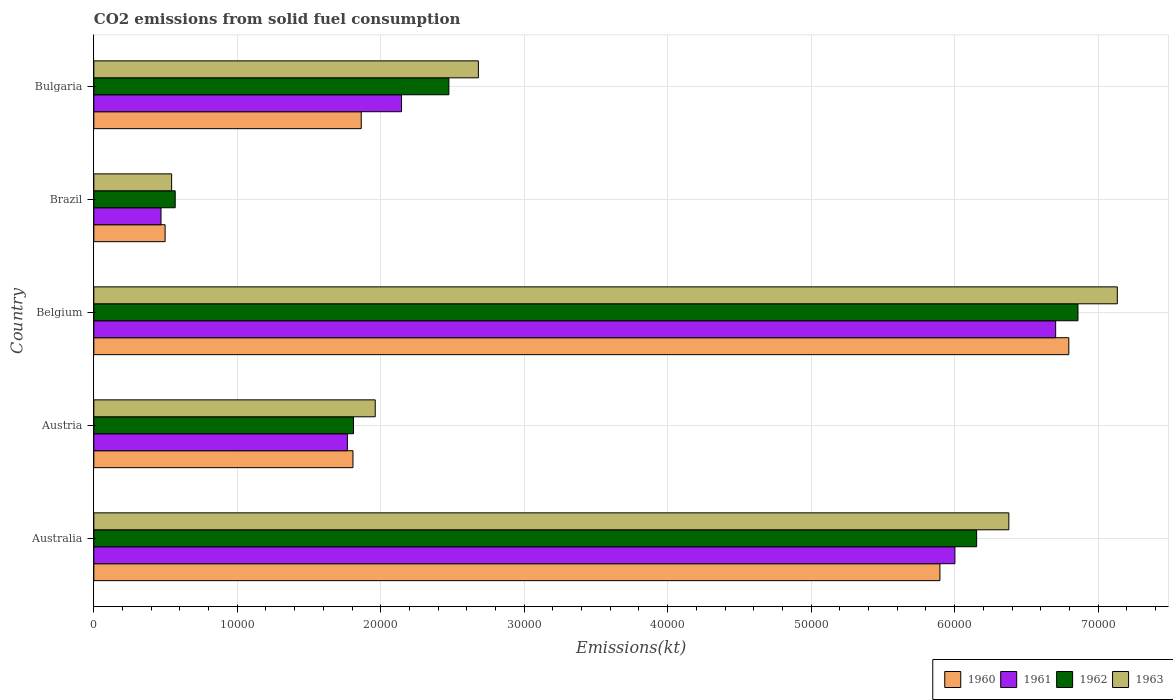How many different coloured bars are there?
Provide a succinct answer. 4. Are the number of bars on each tick of the Y-axis equal?
Your response must be concise. Yes. How many bars are there on the 5th tick from the bottom?
Make the answer very short. 4. What is the amount of CO2 emitted in 1960 in Austria?
Your answer should be compact. 1.81e+04. Across all countries, what is the maximum amount of CO2 emitted in 1961?
Ensure brevity in your answer.  6.70e+04. Across all countries, what is the minimum amount of CO2 emitted in 1962?
Give a very brief answer. 5672.85. In which country was the amount of CO2 emitted in 1960 maximum?
Your response must be concise. Belgium. What is the total amount of CO2 emitted in 1960 in the graph?
Provide a short and direct response. 1.69e+05. What is the difference between the amount of CO2 emitted in 1963 in Australia and that in Belgium?
Provide a succinct answer. -7561.35. What is the difference between the amount of CO2 emitted in 1962 in Australia and the amount of CO2 emitted in 1960 in Bulgaria?
Give a very brief answer. 4.29e+04. What is the average amount of CO2 emitted in 1961 per country?
Give a very brief answer. 3.42e+04. What is the difference between the amount of CO2 emitted in 1960 and amount of CO2 emitted in 1962 in Austria?
Keep it short and to the point. -36.67. In how many countries, is the amount of CO2 emitted in 1961 greater than 8000 kt?
Give a very brief answer. 4. What is the ratio of the amount of CO2 emitted in 1960 in Austria to that in Bulgaria?
Offer a very short reply. 0.97. Is the amount of CO2 emitted in 1962 in Belgium less than that in Brazil?
Make the answer very short. No. What is the difference between the highest and the second highest amount of CO2 emitted in 1963?
Keep it short and to the point. 7561.35. What is the difference between the highest and the lowest amount of CO2 emitted in 1962?
Make the answer very short. 6.29e+04. In how many countries, is the amount of CO2 emitted in 1961 greater than the average amount of CO2 emitted in 1961 taken over all countries?
Your response must be concise. 2. Is it the case that in every country, the sum of the amount of CO2 emitted in 1960 and amount of CO2 emitted in 1962 is greater than the sum of amount of CO2 emitted in 1963 and amount of CO2 emitted in 1961?
Offer a terse response. No. What does the 3rd bar from the top in Austria represents?
Offer a terse response. 1961. What does the 4th bar from the bottom in Bulgaria represents?
Offer a very short reply. 1963. How many bars are there?
Keep it short and to the point. 20. Are all the bars in the graph horizontal?
Give a very brief answer. Yes. How many countries are there in the graph?
Give a very brief answer. 5. What is the difference between two consecutive major ticks on the X-axis?
Give a very brief answer. 10000. Does the graph contain any zero values?
Give a very brief answer. No. Does the graph contain grids?
Your answer should be compact. Yes. What is the title of the graph?
Offer a terse response. CO2 emissions from solid fuel consumption. Does "1968" appear as one of the legend labels in the graph?
Keep it short and to the point. No. What is the label or title of the X-axis?
Your response must be concise. Emissions(kt). What is the label or title of the Y-axis?
Your answer should be very brief. Country. What is the Emissions(kt) in 1960 in Australia?
Your answer should be compact. 5.90e+04. What is the Emissions(kt) in 1961 in Australia?
Provide a short and direct response. 6.00e+04. What is the Emissions(kt) of 1962 in Australia?
Provide a short and direct response. 6.15e+04. What is the Emissions(kt) of 1963 in Australia?
Make the answer very short. 6.38e+04. What is the Emissions(kt) of 1960 in Austria?
Ensure brevity in your answer.  1.81e+04. What is the Emissions(kt) in 1961 in Austria?
Give a very brief answer. 1.77e+04. What is the Emissions(kt) in 1962 in Austria?
Give a very brief answer. 1.81e+04. What is the Emissions(kt) of 1963 in Austria?
Provide a short and direct response. 1.96e+04. What is the Emissions(kt) of 1960 in Belgium?
Ensure brevity in your answer.  6.80e+04. What is the Emissions(kt) in 1961 in Belgium?
Provide a short and direct response. 6.70e+04. What is the Emissions(kt) of 1962 in Belgium?
Provide a short and direct response. 6.86e+04. What is the Emissions(kt) in 1963 in Belgium?
Offer a very short reply. 7.13e+04. What is the Emissions(kt) in 1960 in Brazil?
Provide a succinct answer. 4968.78. What is the Emissions(kt) in 1961 in Brazil?
Your answer should be very brief. 4682.76. What is the Emissions(kt) of 1962 in Brazil?
Keep it short and to the point. 5672.85. What is the Emissions(kt) of 1963 in Brazil?
Make the answer very short. 5423.49. What is the Emissions(kt) of 1960 in Bulgaria?
Give a very brief answer. 1.86e+04. What is the Emissions(kt) in 1961 in Bulgaria?
Provide a short and direct response. 2.14e+04. What is the Emissions(kt) of 1962 in Bulgaria?
Ensure brevity in your answer.  2.47e+04. What is the Emissions(kt) in 1963 in Bulgaria?
Ensure brevity in your answer.  2.68e+04. Across all countries, what is the maximum Emissions(kt) of 1960?
Offer a terse response. 6.80e+04. Across all countries, what is the maximum Emissions(kt) of 1961?
Make the answer very short. 6.70e+04. Across all countries, what is the maximum Emissions(kt) of 1962?
Give a very brief answer. 6.86e+04. Across all countries, what is the maximum Emissions(kt) in 1963?
Give a very brief answer. 7.13e+04. Across all countries, what is the minimum Emissions(kt) of 1960?
Ensure brevity in your answer.  4968.78. Across all countries, what is the minimum Emissions(kt) in 1961?
Ensure brevity in your answer.  4682.76. Across all countries, what is the minimum Emissions(kt) in 1962?
Your answer should be compact. 5672.85. Across all countries, what is the minimum Emissions(kt) of 1963?
Offer a terse response. 5423.49. What is the total Emissions(kt) of 1960 in the graph?
Give a very brief answer. 1.69e+05. What is the total Emissions(kt) of 1961 in the graph?
Make the answer very short. 1.71e+05. What is the total Emissions(kt) in 1962 in the graph?
Provide a short and direct response. 1.79e+05. What is the total Emissions(kt) of 1963 in the graph?
Your answer should be very brief. 1.87e+05. What is the difference between the Emissions(kt) in 1960 in Australia and that in Austria?
Ensure brevity in your answer.  4.09e+04. What is the difference between the Emissions(kt) in 1961 in Australia and that in Austria?
Give a very brief answer. 4.23e+04. What is the difference between the Emissions(kt) of 1962 in Australia and that in Austria?
Ensure brevity in your answer.  4.34e+04. What is the difference between the Emissions(kt) of 1963 in Australia and that in Austria?
Keep it short and to the point. 4.42e+04. What is the difference between the Emissions(kt) in 1960 in Australia and that in Belgium?
Your answer should be compact. -8984.15. What is the difference between the Emissions(kt) in 1961 in Australia and that in Belgium?
Make the answer very short. -7022.31. What is the difference between the Emissions(kt) of 1962 in Australia and that in Belgium?
Your answer should be very brief. -7062.64. What is the difference between the Emissions(kt) of 1963 in Australia and that in Belgium?
Make the answer very short. -7561.35. What is the difference between the Emissions(kt) of 1960 in Australia and that in Brazil?
Ensure brevity in your answer.  5.40e+04. What is the difference between the Emissions(kt) in 1961 in Australia and that in Brazil?
Your response must be concise. 5.53e+04. What is the difference between the Emissions(kt) of 1962 in Australia and that in Brazil?
Your answer should be compact. 5.59e+04. What is the difference between the Emissions(kt) of 1963 in Australia and that in Brazil?
Your response must be concise. 5.84e+04. What is the difference between the Emissions(kt) of 1960 in Australia and that in Bulgaria?
Make the answer very short. 4.03e+04. What is the difference between the Emissions(kt) in 1961 in Australia and that in Bulgaria?
Provide a short and direct response. 3.86e+04. What is the difference between the Emissions(kt) of 1962 in Australia and that in Bulgaria?
Offer a terse response. 3.68e+04. What is the difference between the Emissions(kt) in 1963 in Australia and that in Bulgaria?
Offer a terse response. 3.70e+04. What is the difference between the Emissions(kt) of 1960 in Austria and that in Belgium?
Your response must be concise. -4.99e+04. What is the difference between the Emissions(kt) of 1961 in Austria and that in Belgium?
Your response must be concise. -4.94e+04. What is the difference between the Emissions(kt) of 1962 in Austria and that in Belgium?
Provide a succinct answer. -5.05e+04. What is the difference between the Emissions(kt) of 1963 in Austria and that in Belgium?
Give a very brief answer. -5.17e+04. What is the difference between the Emissions(kt) in 1960 in Austria and that in Brazil?
Provide a short and direct response. 1.31e+04. What is the difference between the Emissions(kt) of 1961 in Austria and that in Brazil?
Ensure brevity in your answer.  1.30e+04. What is the difference between the Emissions(kt) of 1962 in Austria and that in Brazil?
Offer a very short reply. 1.24e+04. What is the difference between the Emissions(kt) of 1963 in Austria and that in Brazil?
Your response must be concise. 1.42e+04. What is the difference between the Emissions(kt) of 1960 in Austria and that in Bulgaria?
Offer a terse response. -575.72. What is the difference between the Emissions(kt) in 1961 in Austria and that in Bulgaria?
Make the answer very short. -3773.34. What is the difference between the Emissions(kt) of 1962 in Austria and that in Bulgaria?
Keep it short and to the point. -6648.27. What is the difference between the Emissions(kt) in 1963 in Austria and that in Bulgaria?
Give a very brief answer. -7190.99. What is the difference between the Emissions(kt) of 1960 in Belgium and that in Brazil?
Your answer should be compact. 6.30e+04. What is the difference between the Emissions(kt) of 1961 in Belgium and that in Brazil?
Make the answer very short. 6.24e+04. What is the difference between the Emissions(kt) in 1962 in Belgium and that in Brazil?
Ensure brevity in your answer.  6.29e+04. What is the difference between the Emissions(kt) in 1963 in Belgium and that in Brazil?
Your answer should be compact. 6.59e+04. What is the difference between the Emissions(kt) of 1960 in Belgium and that in Bulgaria?
Keep it short and to the point. 4.93e+04. What is the difference between the Emissions(kt) in 1961 in Belgium and that in Bulgaria?
Give a very brief answer. 4.56e+04. What is the difference between the Emissions(kt) in 1962 in Belgium and that in Bulgaria?
Provide a succinct answer. 4.38e+04. What is the difference between the Emissions(kt) in 1963 in Belgium and that in Bulgaria?
Your answer should be very brief. 4.45e+04. What is the difference between the Emissions(kt) in 1960 in Brazil and that in Bulgaria?
Give a very brief answer. -1.37e+04. What is the difference between the Emissions(kt) of 1961 in Brazil and that in Bulgaria?
Offer a terse response. -1.68e+04. What is the difference between the Emissions(kt) of 1962 in Brazil and that in Bulgaria?
Your answer should be very brief. -1.91e+04. What is the difference between the Emissions(kt) in 1963 in Brazil and that in Bulgaria?
Give a very brief answer. -2.14e+04. What is the difference between the Emissions(kt) in 1960 in Australia and the Emissions(kt) in 1961 in Austria?
Ensure brevity in your answer.  4.13e+04. What is the difference between the Emissions(kt) of 1960 in Australia and the Emissions(kt) of 1962 in Austria?
Your answer should be compact. 4.09e+04. What is the difference between the Emissions(kt) of 1960 in Australia and the Emissions(kt) of 1963 in Austria?
Offer a very short reply. 3.94e+04. What is the difference between the Emissions(kt) of 1961 in Australia and the Emissions(kt) of 1962 in Austria?
Provide a short and direct response. 4.19e+04. What is the difference between the Emissions(kt) of 1961 in Australia and the Emissions(kt) of 1963 in Austria?
Your response must be concise. 4.04e+04. What is the difference between the Emissions(kt) of 1962 in Australia and the Emissions(kt) of 1963 in Austria?
Your answer should be very brief. 4.19e+04. What is the difference between the Emissions(kt) of 1960 in Australia and the Emissions(kt) of 1961 in Belgium?
Make the answer very short. -8067.4. What is the difference between the Emissions(kt) in 1960 in Australia and the Emissions(kt) in 1962 in Belgium?
Provide a short and direct response. -9622.21. What is the difference between the Emissions(kt) of 1960 in Australia and the Emissions(kt) of 1963 in Belgium?
Your answer should be very brief. -1.24e+04. What is the difference between the Emissions(kt) in 1961 in Australia and the Emissions(kt) in 1962 in Belgium?
Offer a terse response. -8577.11. What is the difference between the Emissions(kt) of 1961 in Australia and the Emissions(kt) of 1963 in Belgium?
Your response must be concise. -1.13e+04. What is the difference between the Emissions(kt) in 1962 in Australia and the Emissions(kt) in 1963 in Belgium?
Offer a terse response. -9805.56. What is the difference between the Emissions(kt) in 1960 in Australia and the Emissions(kt) in 1961 in Brazil?
Your answer should be compact. 5.43e+04. What is the difference between the Emissions(kt) of 1960 in Australia and the Emissions(kt) of 1962 in Brazil?
Your response must be concise. 5.33e+04. What is the difference between the Emissions(kt) in 1960 in Australia and the Emissions(kt) in 1963 in Brazil?
Your response must be concise. 5.36e+04. What is the difference between the Emissions(kt) of 1961 in Australia and the Emissions(kt) of 1962 in Brazil?
Your answer should be compact. 5.43e+04. What is the difference between the Emissions(kt) in 1961 in Australia and the Emissions(kt) in 1963 in Brazil?
Offer a very short reply. 5.46e+04. What is the difference between the Emissions(kt) in 1962 in Australia and the Emissions(kt) in 1963 in Brazil?
Your response must be concise. 5.61e+04. What is the difference between the Emissions(kt) in 1960 in Australia and the Emissions(kt) in 1961 in Bulgaria?
Keep it short and to the point. 3.75e+04. What is the difference between the Emissions(kt) of 1960 in Australia and the Emissions(kt) of 1962 in Bulgaria?
Ensure brevity in your answer.  3.42e+04. What is the difference between the Emissions(kt) in 1960 in Australia and the Emissions(kt) in 1963 in Bulgaria?
Make the answer very short. 3.22e+04. What is the difference between the Emissions(kt) of 1961 in Australia and the Emissions(kt) of 1962 in Bulgaria?
Your answer should be compact. 3.53e+04. What is the difference between the Emissions(kt) of 1961 in Australia and the Emissions(kt) of 1963 in Bulgaria?
Offer a terse response. 3.32e+04. What is the difference between the Emissions(kt) in 1962 in Australia and the Emissions(kt) in 1963 in Bulgaria?
Your answer should be very brief. 3.47e+04. What is the difference between the Emissions(kt) of 1960 in Austria and the Emissions(kt) of 1961 in Belgium?
Give a very brief answer. -4.90e+04. What is the difference between the Emissions(kt) of 1960 in Austria and the Emissions(kt) of 1962 in Belgium?
Ensure brevity in your answer.  -5.05e+04. What is the difference between the Emissions(kt) of 1960 in Austria and the Emissions(kt) of 1963 in Belgium?
Make the answer very short. -5.33e+04. What is the difference between the Emissions(kt) of 1961 in Austria and the Emissions(kt) of 1962 in Belgium?
Your response must be concise. -5.09e+04. What is the difference between the Emissions(kt) in 1961 in Austria and the Emissions(kt) in 1963 in Belgium?
Offer a very short reply. -5.37e+04. What is the difference between the Emissions(kt) of 1962 in Austria and the Emissions(kt) of 1963 in Belgium?
Offer a terse response. -5.32e+04. What is the difference between the Emissions(kt) of 1960 in Austria and the Emissions(kt) of 1961 in Brazil?
Offer a terse response. 1.34e+04. What is the difference between the Emissions(kt) in 1960 in Austria and the Emissions(kt) in 1962 in Brazil?
Provide a short and direct response. 1.24e+04. What is the difference between the Emissions(kt) in 1960 in Austria and the Emissions(kt) in 1963 in Brazil?
Your answer should be compact. 1.26e+04. What is the difference between the Emissions(kt) in 1961 in Austria and the Emissions(kt) in 1962 in Brazil?
Your response must be concise. 1.20e+04. What is the difference between the Emissions(kt) of 1961 in Austria and the Emissions(kt) of 1963 in Brazil?
Offer a very short reply. 1.23e+04. What is the difference between the Emissions(kt) in 1962 in Austria and the Emissions(kt) in 1963 in Brazil?
Your answer should be very brief. 1.27e+04. What is the difference between the Emissions(kt) of 1960 in Austria and the Emissions(kt) of 1961 in Bulgaria?
Give a very brief answer. -3384.64. What is the difference between the Emissions(kt) of 1960 in Austria and the Emissions(kt) of 1962 in Bulgaria?
Offer a very short reply. -6684.94. What is the difference between the Emissions(kt) in 1960 in Austria and the Emissions(kt) in 1963 in Bulgaria?
Provide a succinct answer. -8742.13. What is the difference between the Emissions(kt) of 1961 in Austria and the Emissions(kt) of 1962 in Bulgaria?
Your answer should be very brief. -7073.64. What is the difference between the Emissions(kt) in 1961 in Austria and the Emissions(kt) in 1963 in Bulgaria?
Offer a very short reply. -9130.83. What is the difference between the Emissions(kt) in 1962 in Austria and the Emissions(kt) in 1963 in Bulgaria?
Ensure brevity in your answer.  -8705.46. What is the difference between the Emissions(kt) in 1960 in Belgium and the Emissions(kt) in 1961 in Brazil?
Offer a very short reply. 6.33e+04. What is the difference between the Emissions(kt) of 1960 in Belgium and the Emissions(kt) of 1962 in Brazil?
Keep it short and to the point. 6.23e+04. What is the difference between the Emissions(kt) of 1960 in Belgium and the Emissions(kt) of 1963 in Brazil?
Make the answer very short. 6.25e+04. What is the difference between the Emissions(kt) in 1961 in Belgium and the Emissions(kt) in 1962 in Brazil?
Your response must be concise. 6.14e+04. What is the difference between the Emissions(kt) of 1961 in Belgium and the Emissions(kt) of 1963 in Brazil?
Provide a short and direct response. 6.16e+04. What is the difference between the Emissions(kt) of 1962 in Belgium and the Emissions(kt) of 1963 in Brazil?
Make the answer very short. 6.32e+04. What is the difference between the Emissions(kt) in 1960 in Belgium and the Emissions(kt) in 1961 in Bulgaria?
Give a very brief answer. 4.65e+04. What is the difference between the Emissions(kt) of 1960 in Belgium and the Emissions(kt) of 1962 in Bulgaria?
Provide a succinct answer. 4.32e+04. What is the difference between the Emissions(kt) in 1960 in Belgium and the Emissions(kt) in 1963 in Bulgaria?
Provide a succinct answer. 4.12e+04. What is the difference between the Emissions(kt) in 1961 in Belgium and the Emissions(kt) in 1962 in Bulgaria?
Offer a terse response. 4.23e+04. What is the difference between the Emissions(kt) in 1961 in Belgium and the Emissions(kt) in 1963 in Bulgaria?
Provide a short and direct response. 4.02e+04. What is the difference between the Emissions(kt) in 1962 in Belgium and the Emissions(kt) in 1963 in Bulgaria?
Offer a terse response. 4.18e+04. What is the difference between the Emissions(kt) of 1960 in Brazil and the Emissions(kt) of 1961 in Bulgaria?
Provide a succinct answer. -1.65e+04. What is the difference between the Emissions(kt) of 1960 in Brazil and the Emissions(kt) of 1962 in Bulgaria?
Offer a terse response. -1.98e+04. What is the difference between the Emissions(kt) of 1960 in Brazil and the Emissions(kt) of 1963 in Bulgaria?
Your answer should be compact. -2.18e+04. What is the difference between the Emissions(kt) of 1961 in Brazil and the Emissions(kt) of 1962 in Bulgaria?
Provide a short and direct response. -2.01e+04. What is the difference between the Emissions(kt) in 1961 in Brazil and the Emissions(kt) in 1963 in Bulgaria?
Ensure brevity in your answer.  -2.21e+04. What is the difference between the Emissions(kt) of 1962 in Brazil and the Emissions(kt) of 1963 in Bulgaria?
Provide a short and direct response. -2.11e+04. What is the average Emissions(kt) in 1960 per country?
Offer a terse response. 3.37e+04. What is the average Emissions(kt) of 1961 per country?
Ensure brevity in your answer.  3.42e+04. What is the average Emissions(kt) in 1962 per country?
Ensure brevity in your answer.  3.57e+04. What is the average Emissions(kt) of 1963 per country?
Your response must be concise. 3.74e+04. What is the difference between the Emissions(kt) of 1960 and Emissions(kt) of 1961 in Australia?
Provide a succinct answer. -1045.1. What is the difference between the Emissions(kt) of 1960 and Emissions(kt) of 1962 in Australia?
Offer a very short reply. -2559.57. What is the difference between the Emissions(kt) of 1960 and Emissions(kt) of 1963 in Australia?
Offer a terse response. -4803.77. What is the difference between the Emissions(kt) of 1961 and Emissions(kt) of 1962 in Australia?
Your response must be concise. -1514.47. What is the difference between the Emissions(kt) in 1961 and Emissions(kt) in 1963 in Australia?
Make the answer very short. -3758.68. What is the difference between the Emissions(kt) in 1962 and Emissions(kt) in 1963 in Australia?
Offer a terse response. -2244.2. What is the difference between the Emissions(kt) in 1960 and Emissions(kt) in 1961 in Austria?
Provide a short and direct response. 388.7. What is the difference between the Emissions(kt) in 1960 and Emissions(kt) in 1962 in Austria?
Provide a short and direct response. -36.67. What is the difference between the Emissions(kt) in 1960 and Emissions(kt) in 1963 in Austria?
Make the answer very short. -1551.14. What is the difference between the Emissions(kt) of 1961 and Emissions(kt) of 1962 in Austria?
Make the answer very short. -425.37. What is the difference between the Emissions(kt) in 1961 and Emissions(kt) in 1963 in Austria?
Provide a short and direct response. -1939.84. What is the difference between the Emissions(kt) of 1962 and Emissions(kt) of 1963 in Austria?
Provide a short and direct response. -1514.47. What is the difference between the Emissions(kt) in 1960 and Emissions(kt) in 1961 in Belgium?
Your answer should be compact. 916.75. What is the difference between the Emissions(kt) in 1960 and Emissions(kt) in 1962 in Belgium?
Make the answer very short. -638.06. What is the difference between the Emissions(kt) in 1960 and Emissions(kt) in 1963 in Belgium?
Your answer should be very brief. -3380.97. What is the difference between the Emissions(kt) in 1961 and Emissions(kt) in 1962 in Belgium?
Offer a terse response. -1554.81. What is the difference between the Emissions(kt) of 1961 and Emissions(kt) of 1963 in Belgium?
Your answer should be very brief. -4297.72. What is the difference between the Emissions(kt) in 1962 and Emissions(kt) in 1963 in Belgium?
Your answer should be very brief. -2742.92. What is the difference between the Emissions(kt) of 1960 and Emissions(kt) of 1961 in Brazil?
Your answer should be very brief. 286.03. What is the difference between the Emissions(kt) of 1960 and Emissions(kt) of 1962 in Brazil?
Your response must be concise. -704.06. What is the difference between the Emissions(kt) of 1960 and Emissions(kt) of 1963 in Brazil?
Make the answer very short. -454.71. What is the difference between the Emissions(kt) in 1961 and Emissions(kt) in 1962 in Brazil?
Give a very brief answer. -990.09. What is the difference between the Emissions(kt) in 1961 and Emissions(kt) in 1963 in Brazil?
Your answer should be very brief. -740.73. What is the difference between the Emissions(kt) of 1962 and Emissions(kt) of 1963 in Brazil?
Provide a succinct answer. 249.36. What is the difference between the Emissions(kt) in 1960 and Emissions(kt) in 1961 in Bulgaria?
Make the answer very short. -2808.92. What is the difference between the Emissions(kt) in 1960 and Emissions(kt) in 1962 in Bulgaria?
Your response must be concise. -6109.22. What is the difference between the Emissions(kt) in 1960 and Emissions(kt) in 1963 in Bulgaria?
Give a very brief answer. -8166.41. What is the difference between the Emissions(kt) in 1961 and Emissions(kt) in 1962 in Bulgaria?
Ensure brevity in your answer.  -3300.3. What is the difference between the Emissions(kt) of 1961 and Emissions(kt) of 1963 in Bulgaria?
Provide a succinct answer. -5357.49. What is the difference between the Emissions(kt) in 1962 and Emissions(kt) in 1963 in Bulgaria?
Ensure brevity in your answer.  -2057.19. What is the ratio of the Emissions(kt) of 1960 in Australia to that in Austria?
Ensure brevity in your answer.  3.26. What is the ratio of the Emissions(kt) in 1961 in Australia to that in Austria?
Make the answer very short. 3.4. What is the ratio of the Emissions(kt) of 1962 in Australia to that in Austria?
Your response must be concise. 3.4. What is the ratio of the Emissions(kt) of 1963 in Australia to that in Austria?
Your answer should be compact. 3.25. What is the ratio of the Emissions(kt) of 1960 in Australia to that in Belgium?
Provide a succinct answer. 0.87. What is the ratio of the Emissions(kt) of 1961 in Australia to that in Belgium?
Ensure brevity in your answer.  0.9. What is the ratio of the Emissions(kt) of 1962 in Australia to that in Belgium?
Provide a short and direct response. 0.9. What is the ratio of the Emissions(kt) of 1963 in Australia to that in Belgium?
Provide a succinct answer. 0.89. What is the ratio of the Emissions(kt) of 1960 in Australia to that in Brazil?
Your response must be concise. 11.87. What is the ratio of the Emissions(kt) of 1961 in Australia to that in Brazil?
Provide a succinct answer. 12.82. What is the ratio of the Emissions(kt) in 1962 in Australia to that in Brazil?
Provide a short and direct response. 10.85. What is the ratio of the Emissions(kt) in 1963 in Australia to that in Brazil?
Give a very brief answer. 11.76. What is the ratio of the Emissions(kt) of 1960 in Australia to that in Bulgaria?
Make the answer very short. 3.16. What is the ratio of the Emissions(kt) in 1961 in Australia to that in Bulgaria?
Provide a short and direct response. 2.8. What is the ratio of the Emissions(kt) in 1962 in Australia to that in Bulgaria?
Give a very brief answer. 2.49. What is the ratio of the Emissions(kt) of 1963 in Australia to that in Bulgaria?
Provide a short and direct response. 2.38. What is the ratio of the Emissions(kt) of 1960 in Austria to that in Belgium?
Offer a terse response. 0.27. What is the ratio of the Emissions(kt) of 1961 in Austria to that in Belgium?
Make the answer very short. 0.26. What is the ratio of the Emissions(kt) in 1962 in Austria to that in Belgium?
Your answer should be very brief. 0.26. What is the ratio of the Emissions(kt) in 1963 in Austria to that in Belgium?
Ensure brevity in your answer.  0.27. What is the ratio of the Emissions(kt) of 1960 in Austria to that in Brazil?
Provide a short and direct response. 3.64. What is the ratio of the Emissions(kt) in 1961 in Austria to that in Brazil?
Your answer should be compact. 3.77. What is the ratio of the Emissions(kt) in 1962 in Austria to that in Brazil?
Your response must be concise. 3.19. What is the ratio of the Emissions(kt) in 1963 in Austria to that in Brazil?
Your response must be concise. 3.62. What is the ratio of the Emissions(kt) of 1960 in Austria to that in Bulgaria?
Give a very brief answer. 0.97. What is the ratio of the Emissions(kt) of 1961 in Austria to that in Bulgaria?
Your answer should be compact. 0.82. What is the ratio of the Emissions(kt) of 1962 in Austria to that in Bulgaria?
Your answer should be compact. 0.73. What is the ratio of the Emissions(kt) of 1963 in Austria to that in Bulgaria?
Provide a short and direct response. 0.73. What is the ratio of the Emissions(kt) in 1960 in Belgium to that in Brazil?
Offer a terse response. 13.68. What is the ratio of the Emissions(kt) in 1961 in Belgium to that in Brazil?
Provide a short and direct response. 14.32. What is the ratio of the Emissions(kt) of 1962 in Belgium to that in Brazil?
Keep it short and to the point. 12.09. What is the ratio of the Emissions(kt) of 1963 in Belgium to that in Brazil?
Provide a short and direct response. 13.15. What is the ratio of the Emissions(kt) of 1960 in Belgium to that in Bulgaria?
Offer a terse response. 3.65. What is the ratio of the Emissions(kt) of 1961 in Belgium to that in Bulgaria?
Provide a short and direct response. 3.13. What is the ratio of the Emissions(kt) of 1962 in Belgium to that in Bulgaria?
Make the answer very short. 2.77. What is the ratio of the Emissions(kt) in 1963 in Belgium to that in Bulgaria?
Give a very brief answer. 2.66. What is the ratio of the Emissions(kt) of 1960 in Brazil to that in Bulgaria?
Keep it short and to the point. 0.27. What is the ratio of the Emissions(kt) of 1961 in Brazil to that in Bulgaria?
Your answer should be compact. 0.22. What is the ratio of the Emissions(kt) of 1962 in Brazil to that in Bulgaria?
Your answer should be compact. 0.23. What is the ratio of the Emissions(kt) in 1963 in Brazil to that in Bulgaria?
Your answer should be compact. 0.2. What is the difference between the highest and the second highest Emissions(kt) of 1960?
Keep it short and to the point. 8984.15. What is the difference between the highest and the second highest Emissions(kt) of 1961?
Ensure brevity in your answer.  7022.31. What is the difference between the highest and the second highest Emissions(kt) in 1962?
Provide a short and direct response. 7062.64. What is the difference between the highest and the second highest Emissions(kt) in 1963?
Offer a very short reply. 7561.35. What is the difference between the highest and the lowest Emissions(kt) in 1960?
Keep it short and to the point. 6.30e+04. What is the difference between the highest and the lowest Emissions(kt) in 1961?
Keep it short and to the point. 6.24e+04. What is the difference between the highest and the lowest Emissions(kt) in 1962?
Offer a terse response. 6.29e+04. What is the difference between the highest and the lowest Emissions(kt) in 1963?
Give a very brief answer. 6.59e+04. 